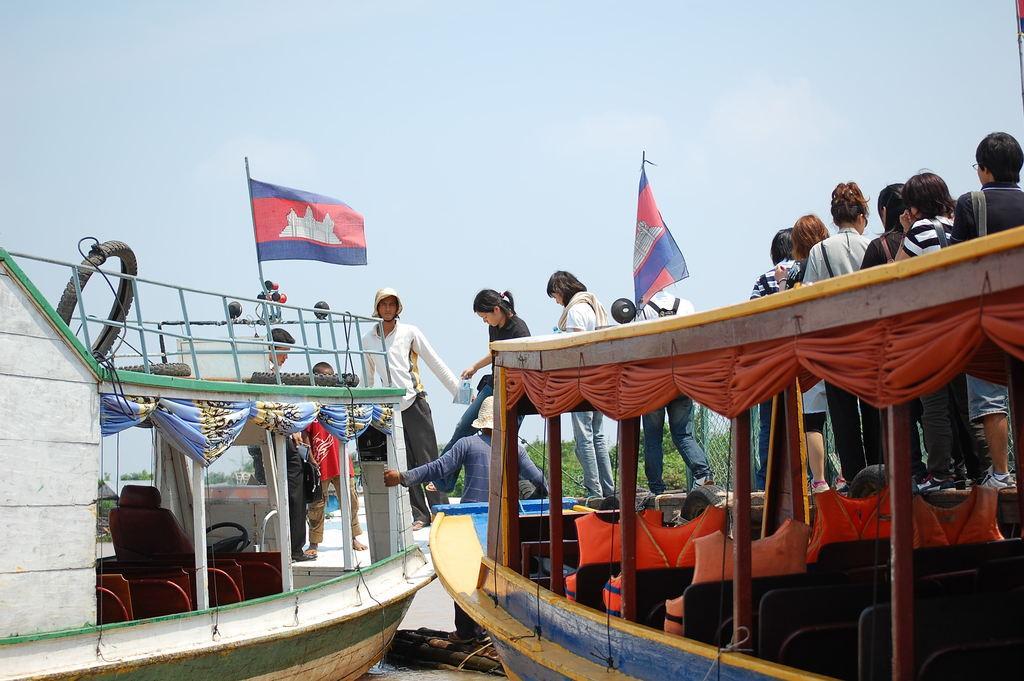In one or two sentences, can you explain what this image depicts? In this image we can see two boats in the water containing some curtains, a metal railing, a tire tied with wires, two flags, some life jackets on the chairs and a steering. We can also see a group of people standing on the boat. On the backside we can see a metal fence, a group of trees and the sky which looks cloudy. 